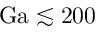<formula> <loc_0><loc_0><loc_500><loc_500>G a \lesssim 2 0 0</formula> 